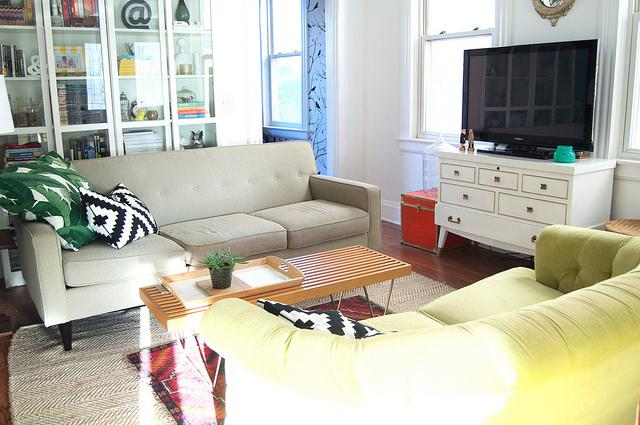What color is the vase on the right side of the white entertainment center? turquoise 